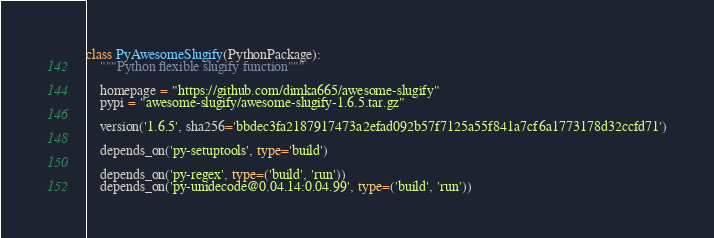Convert code to text. <code><loc_0><loc_0><loc_500><loc_500><_Python_>

class PyAwesomeSlugify(PythonPackage):
    """Python flexible slugify function"""

    homepage = "https://github.com/dimka665/awesome-slugify"
    pypi = "awesome-slugify/awesome-slugify-1.6.5.tar.gz"

    version('1.6.5', sha256='bbdec3fa2187917473a2efad092b57f7125a55f841a7cf6a1773178d32ccfd71')

    depends_on('py-setuptools', type='build')

    depends_on('py-regex', type=('build', 'run'))
    depends_on('py-unidecode@0.04.14:0.04.99', type=('build', 'run'))
</code> 